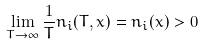<formula> <loc_0><loc_0><loc_500><loc_500>\lim _ { T \rightarrow \infty } \frac { 1 } { T } n _ { i } ( T , x ) = n _ { i } ( x ) > 0</formula> 